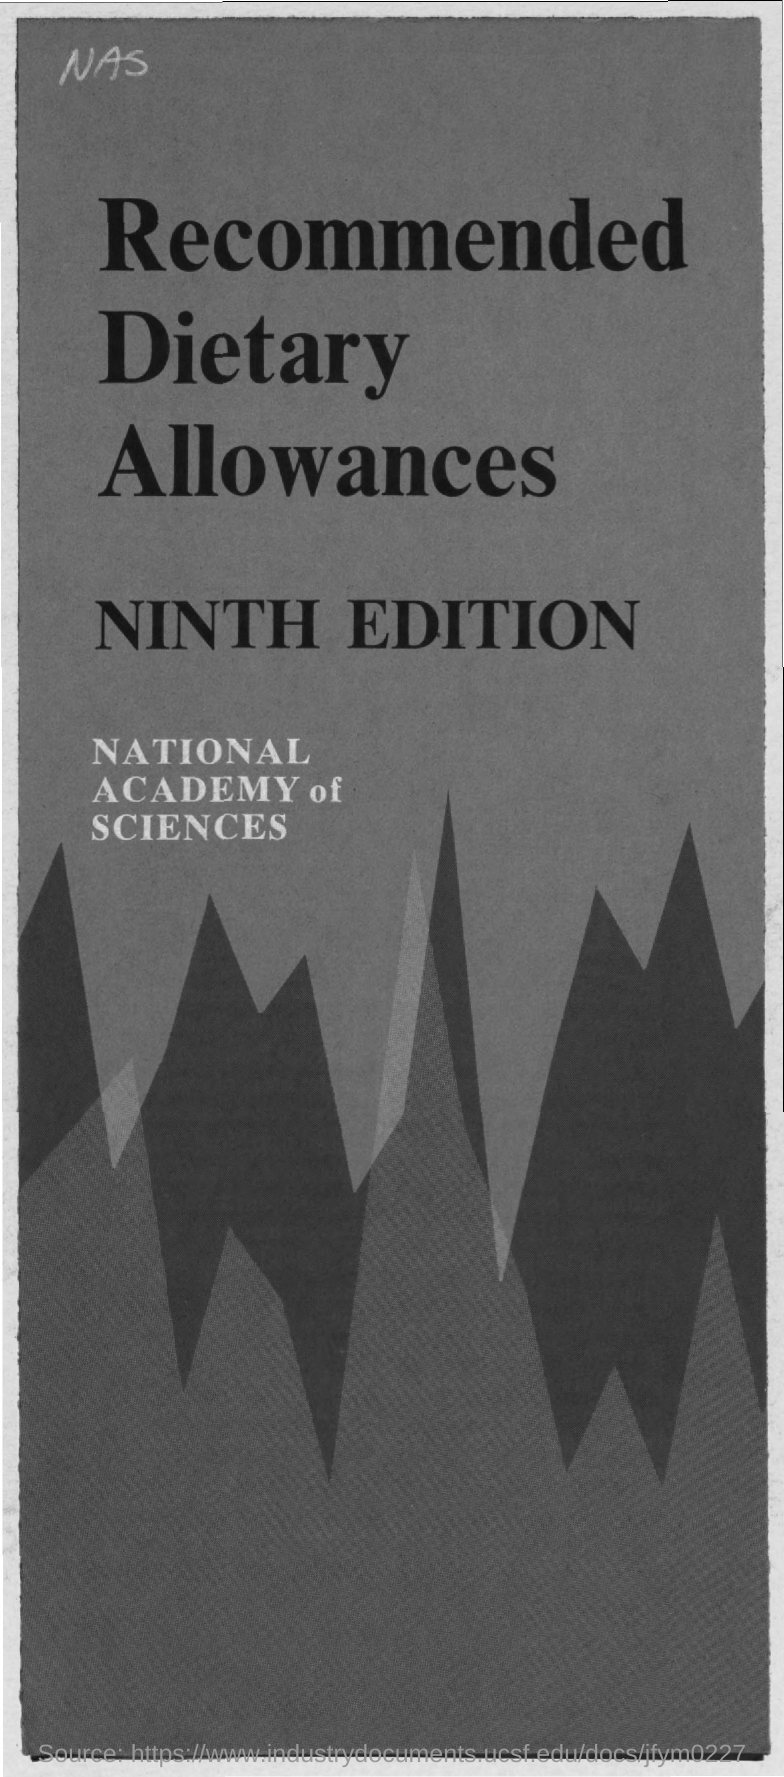Identify some key points in this picture. Allowances mentioned are called Recommended Dietary Allowances. The number of the edition mentioned is the NINTH EDITION. The National Academy of Sciences is the name of the academy that was mentioned. 